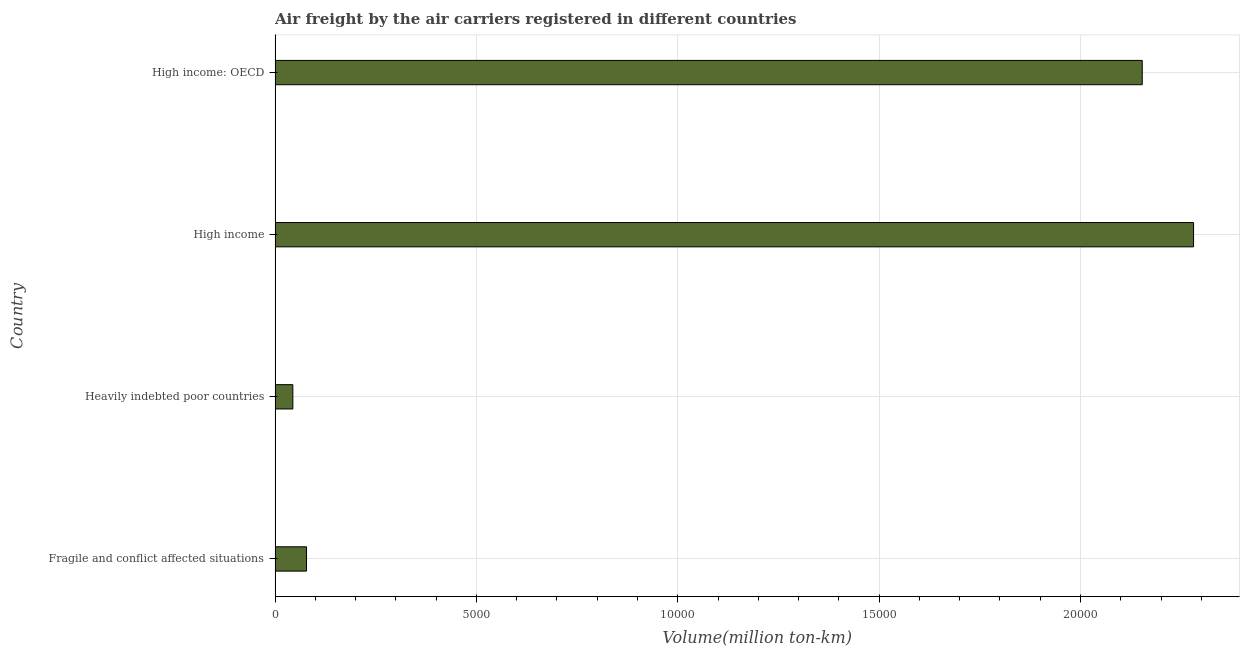Does the graph contain grids?
Provide a succinct answer. Yes. What is the title of the graph?
Ensure brevity in your answer.  Air freight by the air carriers registered in different countries. What is the label or title of the X-axis?
Your response must be concise. Volume(million ton-km). What is the label or title of the Y-axis?
Provide a succinct answer. Country. What is the air freight in High income: OECD?
Your response must be concise. 2.15e+04. Across all countries, what is the maximum air freight?
Provide a succinct answer. 2.28e+04. Across all countries, what is the minimum air freight?
Keep it short and to the point. 441. In which country was the air freight maximum?
Provide a succinct answer. High income. In which country was the air freight minimum?
Give a very brief answer. Heavily indebted poor countries. What is the sum of the air freight?
Your answer should be compact. 4.56e+04. What is the difference between the air freight in Fragile and conflict affected situations and Heavily indebted poor countries?
Ensure brevity in your answer.  339.5. What is the average air freight per country?
Your answer should be compact. 1.14e+04. What is the median air freight?
Make the answer very short. 1.12e+04. In how many countries, is the air freight greater than 22000 million ton-km?
Make the answer very short. 1. What is the ratio of the air freight in High income to that in High income: OECD?
Offer a very short reply. 1.06. What is the difference between the highest and the second highest air freight?
Your response must be concise. 1274.4. What is the difference between the highest and the lowest air freight?
Make the answer very short. 2.24e+04. How many bars are there?
Offer a terse response. 4. Are all the bars in the graph horizontal?
Provide a short and direct response. Yes. How many countries are there in the graph?
Keep it short and to the point. 4. What is the Volume(million ton-km) of Fragile and conflict affected situations?
Offer a very short reply. 780.5. What is the Volume(million ton-km) of Heavily indebted poor countries?
Your answer should be compact. 441. What is the Volume(million ton-km) of High income?
Offer a terse response. 2.28e+04. What is the Volume(million ton-km) in High income: OECD?
Ensure brevity in your answer.  2.15e+04. What is the difference between the Volume(million ton-km) in Fragile and conflict affected situations and Heavily indebted poor countries?
Ensure brevity in your answer.  339.5. What is the difference between the Volume(million ton-km) in Fragile and conflict affected situations and High income?
Ensure brevity in your answer.  -2.20e+04. What is the difference between the Volume(million ton-km) in Fragile and conflict affected situations and High income: OECD?
Keep it short and to the point. -2.08e+04. What is the difference between the Volume(million ton-km) in Heavily indebted poor countries and High income?
Provide a short and direct response. -2.24e+04. What is the difference between the Volume(million ton-km) in Heavily indebted poor countries and High income: OECD?
Make the answer very short. -2.11e+04. What is the difference between the Volume(million ton-km) in High income and High income: OECD?
Your answer should be very brief. 1274.4. What is the ratio of the Volume(million ton-km) in Fragile and conflict affected situations to that in Heavily indebted poor countries?
Offer a very short reply. 1.77. What is the ratio of the Volume(million ton-km) in Fragile and conflict affected situations to that in High income?
Your answer should be very brief. 0.03. What is the ratio of the Volume(million ton-km) in Fragile and conflict affected situations to that in High income: OECD?
Your answer should be very brief. 0.04. What is the ratio of the Volume(million ton-km) in Heavily indebted poor countries to that in High income?
Your response must be concise. 0.02. What is the ratio of the Volume(million ton-km) in High income to that in High income: OECD?
Offer a very short reply. 1.06. 